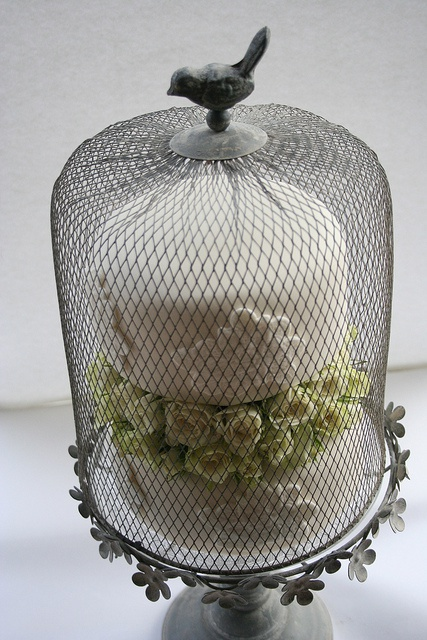Describe the objects in this image and their specific colors. I can see cake in darkgray, lightgray, and gray tones and bird in darkgray, black, gray, and purple tones in this image. 